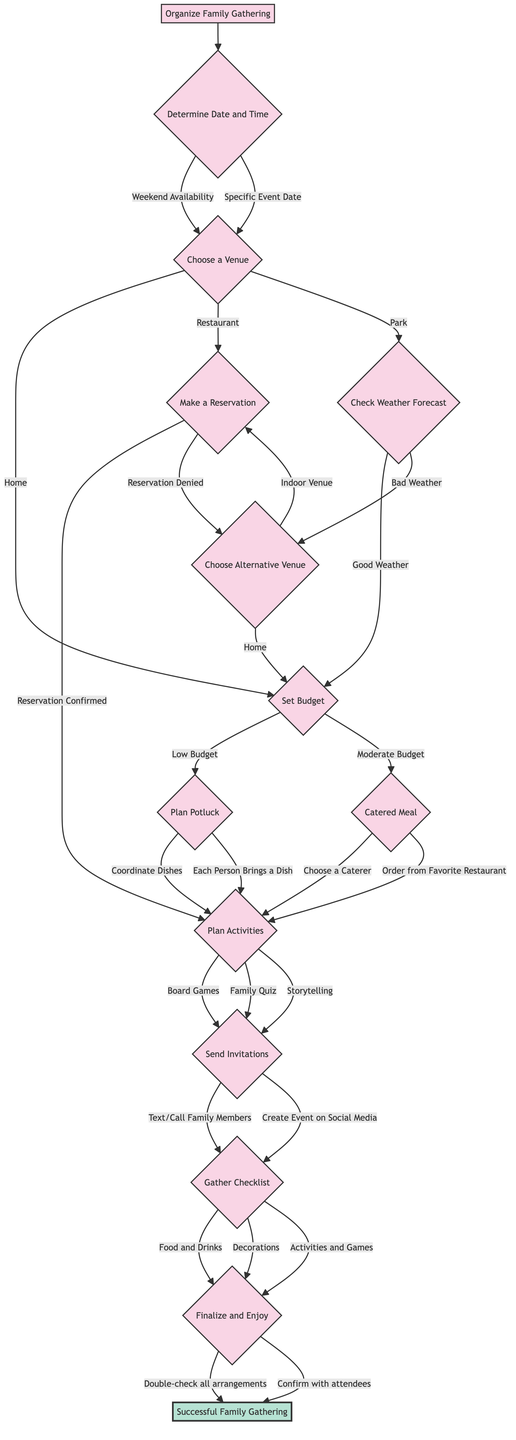What is the first question in the decision tree? The first question in the decision tree is "Determine Date and Time," which is located directly below the initial node "Organize Family Gathering" at the top.
Answer: Determine Date and Time How many options are there for the question "Choose a Venue"? The question "Choose a Venue" has three options: "Home," "Restaurant," and "Park," making a total of three options.
Answer: Three What is the next step after "Set Budget" with a "Moderate Budget"? After "Set Budget," if the option "Moderate Budget" is chosen, the next step is "Catered Meal," as indicated in the flow.
Answer: Catered Meal If the weather forecast is bad, what is the next step after "Check Weather Forecast"? If the weather forecast is bad, the next step after "Check Weather Forecast" is "Choose Alternative Venue," meaning the gathering's location needs to be changed.
Answer: Choose Alternative Venue What options lead to "Plan Activities"? The options that lead to "Plan Activities" are from "Make a Reservation," "Plan Potluck," and "Catered Meal." Each of these steps has paths that lead directly to planning the activities for the gathering.
Answer: Make a Reservation, Plan Potluck, Catered Meal If you choose "Home" as a venue, what is the next step if you later have to choose an alternative venue? If "Home" is chosen and later an alternative venue is needed, the next step will go back to "Set Budget," as indicated in the "Choose Alternative Venue" path.
Answer: Set Budget What happens after sending invitations? After sending invitations, the next step is "Gather Checklist," which involves preparing a list of items needed for the gathering.
Answer: Gather Checklist What is the final outcome of the decision tree? The final outcome of the decision tree, after following all the necessary steps, is "Successful Family Gathering," which is the end goal depicted in the last node.
Answer: Successful Family Gathering 